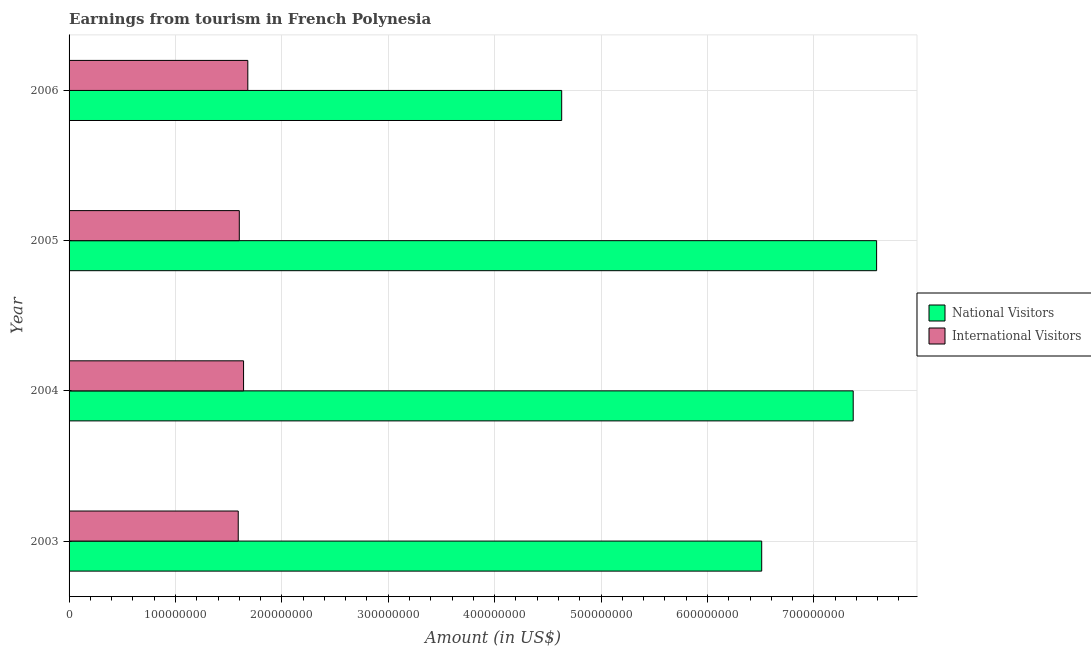How many groups of bars are there?
Provide a succinct answer. 4. Are the number of bars per tick equal to the number of legend labels?
Ensure brevity in your answer.  Yes. Are the number of bars on each tick of the Y-axis equal?
Provide a succinct answer. Yes. How many bars are there on the 1st tick from the top?
Your response must be concise. 2. What is the label of the 2nd group of bars from the top?
Your answer should be very brief. 2005. In how many cases, is the number of bars for a given year not equal to the number of legend labels?
Make the answer very short. 0. What is the amount earned from international visitors in 2005?
Your response must be concise. 1.60e+08. Across all years, what is the maximum amount earned from national visitors?
Give a very brief answer. 7.59e+08. Across all years, what is the minimum amount earned from international visitors?
Offer a terse response. 1.59e+08. In which year was the amount earned from national visitors maximum?
Ensure brevity in your answer.  2005. In which year was the amount earned from national visitors minimum?
Provide a succinct answer. 2006. What is the total amount earned from national visitors in the graph?
Your answer should be compact. 2.61e+09. What is the difference between the amount earned from international visitors in 2004 and that in 2006?
Keep it short and to the point. -4.00e+06. What is the difference between the amount earned from national visitors in 2004 and the amount earned from international visitors in 2005?
Your answer should be compact. 5.77e+08. What is the average amount earned from national visitors per year?
Your answer should be very brief. 6.52e+08. In the year 2003, what is the difference between the amount earned from national visitors and amount earned from international visitors?
Make the answer very short. 4.92e+08. In how many years, is the amount earned from international visitors greater than 360000000 US$?
Offer a very short reply. 0. What is the ratio of the amount earned from national visitors in 2003 to that in 2006?
Provide a succinct answer. 1.41. Is the difference between the amount earned from international visitors in 2003 and 2005 greater than the difference between the amount earned from national visitors in 2003 and 2005?
Provide a succinct answer. Yes. What is the difference between the highest and the second highest amount earned from international visitors?
Provide a short and direct response. 4.00e+06. What is the difference between the highest and the lowest amount earned from international visitors?
Provide a succinct answer. 9.00e+06. In how many years, is the amount earned from national visitors greater than the average amount earned from national visitors taken over all years?
Your response must be concise. 2. Is the sum of the amount earned from national visitors in 2003 and 2004 greater than the maximum amount earned from international visitors across all years?
Provide a short and direct response. Yes. What does the 1st bar from the top in 2006 represents?
Ensure brevity in your answer.  International Visitors. What does the 1st bar from the bottom in 2004 represents?
Give a very brief answer. National Visitors. What is the difference between two consecutive major ticks on the X-axis?
Your answer should be very brief. 1.00e+08. Does the graph contain any zero values?
Your answer should be compact. No. Does the graph contain grids?
Offer a terse response. Yes. Where does the legend appear in the graph?
Offer a very short reply. Center right. How are the legend labels stacked?
Your answer should be very brief. Vertical. What is the title of the graph?
Your response must be concise. Earnings from tourism in French Polynesia. What is the label or title of the Y-axis?
Offer a very short reply. Year. What is the Amount (in US$) in National Visitors in 2003?
Your response must be concise. 6.51e+08. What is the Amount (in US$) in International Visitors in 2003?
Make the answer very short. 1.59e+08. What is the Amount (in US$) of National Visitors in 2004?
Ensure brevity in your answer.  7.37e+08. What is the Amount (in US$) of International Visitors in 2004?
Your answer should be very brief. 1.64e+08. What is the Amount (in US$) in National Visitors in 2005?
Keep it short and to the point. 7.59e+08. What is the Amount (in US$) in International Visitors in 2005?
Give a very brief answer. 1.60e+08. What is the Amount (in US$) of National Visitors in 2006?
Offer a very short reply. 4.63e+08. What is the Amount (in US$) in International Visitors in 2006?
Your answer should be very brief. 1.68e+08. Across all years, what is the maximum Amount (in US$) in National Visitors?
Keep it short and to the point. 7.59e+08. Across all years, what is the maximum Amount (in US$) of International Visitors?
Offer a very short reply. 1.68e+08. Across all years, what is the minimum Amount (in US$) in National Visitors?
Your answer should be very brief. 4.63e+08. Across all years, what is the minimum Amount (in US$) in International Visitors?
Provide a short and direct response. 1.59e+08. What is the total Amount (in US$) of National Visitors in the graph?
Make the answer very short. 2.61e+09. What is the total Amount (in US$) in International Visitors in the graph?
Your answer should be very brief. 6.51e+08. What is the difference between the Amount (in US$) in National Visitors in 2003 and that in 2004?
Give a very brief answer. -8.60e+07. What is the difference between the Amount (in US$) in International Visitors in 2003 and that in 2004?
Your answer should be compact. -5.00e+06. What is the difference between the Amount (in US$) of National Visitors in 2003 and that in 2005?
Provide a short and direct response. -1.08e+08. What is the difference between the Amount (in US$) of International Visitors in 2003 and that in 2005?
Provide a short and direct response. -1.00e+06. What is the difference between the Amount (in US$) in National Visitors in 2003 and that in 2006?
Provide a succinct answer. 1.88e+08. What is the difference between the Amount (in US$) of International Visitors in 2003 and that in 2006?
Give a very brief answer. -9.00e+06. What is the difference between the Amount (in US$) of National Visitors in 2004 and that in 2005?
Your answer should be compact. -2.20e+07. What is the difference between the Amount (in US$) of International Visitors in 2004 and that in 2005?
Keep it short and to the point. 4.00e+06. What is the difference between the Amount (in US$) in National Visitors in 2004 and that in 2006?
Keep it short and to the point. 2.74e+08. What is the difference between the Amount (in US$) of International Visitors in 2004 and that in 2006?
Give a very brief answer. -4.00e+06. What is the difference between the Amount (in US$) in National Visitors in 2005 and that in 2006?
Provide a succinct answer. 2.96e+08. What is the difference between the Amount (in US$) in International Visitors in 2005 and that in 2006?
Ensure brevity in your answer.  -8.00e+06. What is the difference between the Amount (in US$) in National Visitors in 2003 and the Amount (in US$) in International Visitors in 2004?
Provide a succinct answer. 4.87e+08. What is the difference between the Amount (in US$) of National Visitors in 2003 and the Amount (in US$) of International Visitors in 2005?
Your answer should be very brief. 4.91e+08. What is the difference between the Amount (in US$) of National Visitors in 2003 and the Amount (in US$) of International Visitors in 2006?
Your answer should be compact. 4.83e+08. What is the difference between the Amount (in US$) in National Visitors in 2004 and the Amount (in US$) in International Visitors in 2005?
Your answer should be compact. 5.77e+08. What is the difference between the Amount (in US$) in National Visitors in 2004 and the Amount (in US$) in International Visitors in 2006?
Ensure brevity in your answer.  5.69e+08. What is the difference between the Amount (in US$) in National Visitors in 2005 and the Amount (in US$) in International Visitors in 2006?
Make the answer very short. 5.91e+08. What is the average Amount (in US$) of National Visitors per year?
Provide a short and direct response. 6.52e+08. What is the average Amount (in US$) of International Visitors per year?
Give a very brief answer. 1.63e+08. In the year 2003, what is the difference between the Amount (in US$) of National Visitors and Amount (in US$) of International Visitors?
Ensure brevity in your answer.  4.92e+08. In the year 2004, what is the difference between the Amount (in US$) in National Visitors and Amount (in US$) in International Visitors?
Provide a succinct answer. 5.73e+08. In the year 2005, what is the difference between the Amount (in US$) in National Visitors and Amount (in US$) in International Visitors?
Your response must be concise. 5.99e+08. In the year 2006, what is the difference between the Amount (in US$) of National Visitors and Amount (in US$) of International Visitors?
Offer a terse response. 2.95e+08. What is the ratio of the Amount (in US$) in National Visitors in 2003 to that in 2004?
Your answer should be compact. 0.88. What is the ratio of the Amount (in US$) of International Visitors in 2003 to that in 2004?
Keep it short and to the point. 0.97. What is the ratio of the Amount (in US$) of National Visitors in 2003 to that in 2005?
Your response must be concise. 0.86. What is the ratio of the Amount (in US$) of National Visitors in 2003 to that in 2006?
Provide a succinct answer. 1.41. What is the ratio of the Amount (in US$) in International Visitors in 2003 to that in 2006?
Your answer should be compact. 0.95. What is the ratio of the Amount (in US$) in National Visitors in 2004 to that in 2005?
Your answer should be very brief. 0.97. What is the ratio of the Amount (in US$) of National Visitors in 2004 to that in 2006?
Offer a very short reply. 1.59. What is the ratio of the Amount (in US$) of International Visitors in 2004 to that in 2006?
Keep it short and to the point. 0.98. What is the ratio of the Amount (in US$) in National Visitors in 2005 to that in 2006?
Ensure brevity in your answer.  1.64. What is the difference between the highest and the second highest Amount (in US$) of National Visitors?
Your answer should be compact. 2.20e+07. What is the difference between the highest and the lowest Amount (in US$) in National Visitors?
Your answer should be very brief. 2.96e+08. What is the difference between the highest and the lowest Amount (in US$) in International Visitors?
Offer a terse response. 9.00e+06. 